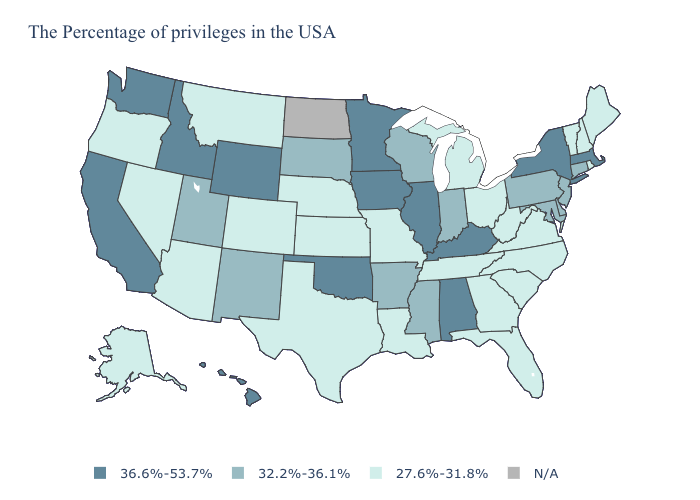Which states have the lowest value in the Northeast?
Be succinct. Maine, Rhode Island, New Hampshire, Vermont. Name the states that have a value in the range 32.2%-36.1%?
Write a very short answer. Connecticut, New Jersey, Delaware, Maryland, Pennsylvania, Indiana, Wisconsin, Mississippi, Arkansas, South Dakota, New Mexico, Utah. What is the value of Mississippi?
Quick response, please. 32.2%-36.1%. What is the highest value in the USA?
Concise answer only. 36.6%-53.7%. What is the lowest value in the USA?
Write a very short answer. 27.6%-31.8%. What is the lowest value in the USA?
Be succinct. 27.6%-31.8%. What is the value of California?
Be succinct. 36.6%-53.7%. Name the states that have a value in the range 36.6%-53.7%?
Answer briefly. Massachusetts, New York, Kentucky, Alabama, Illinois, Minnesota, Iowa, Oklahoma, Wyoming, Idaho, California, Washington, Hawaii. Does the first symbol in the legend represent the smallest category?
Concise answer only. No. Name the states that have a value in the range 32.2%-36.1%?
Be succinct. Connecticut, New Jersey, Delaware, Maryland, Pennsylvania, Indiana, Wisconsin, Mississippi, Arkansas, South Dakota, New Mexico, Utah. What is the value of Nebraska?
Keep it brief. 27.6%-31.8%. Name the states that have a value in the range 27.6%-31.8%?
Quick response, please. Maine, Rhode Island, New Hampshire, Vermont, Virginia, North Carolina, South Carolina, West Virginia, Ohio, Florida, Georgia, Michigan, Tennessee, Louisiana, Missouri, Kansas, Nebraska, Texas, Colorado, Montana, Arizona, Nevada, Oregon, Alaska. What is the highest value in the Northeast ?
Quick response, please. 36.6%-53.7%. 